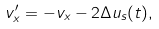<formula> <loc_0><loc_0><loc_500><loc_500>v _ { x } ^ { \prime } = - v _ { x } - 2 \Delta u _ { s } ( t ) ,</formula> 